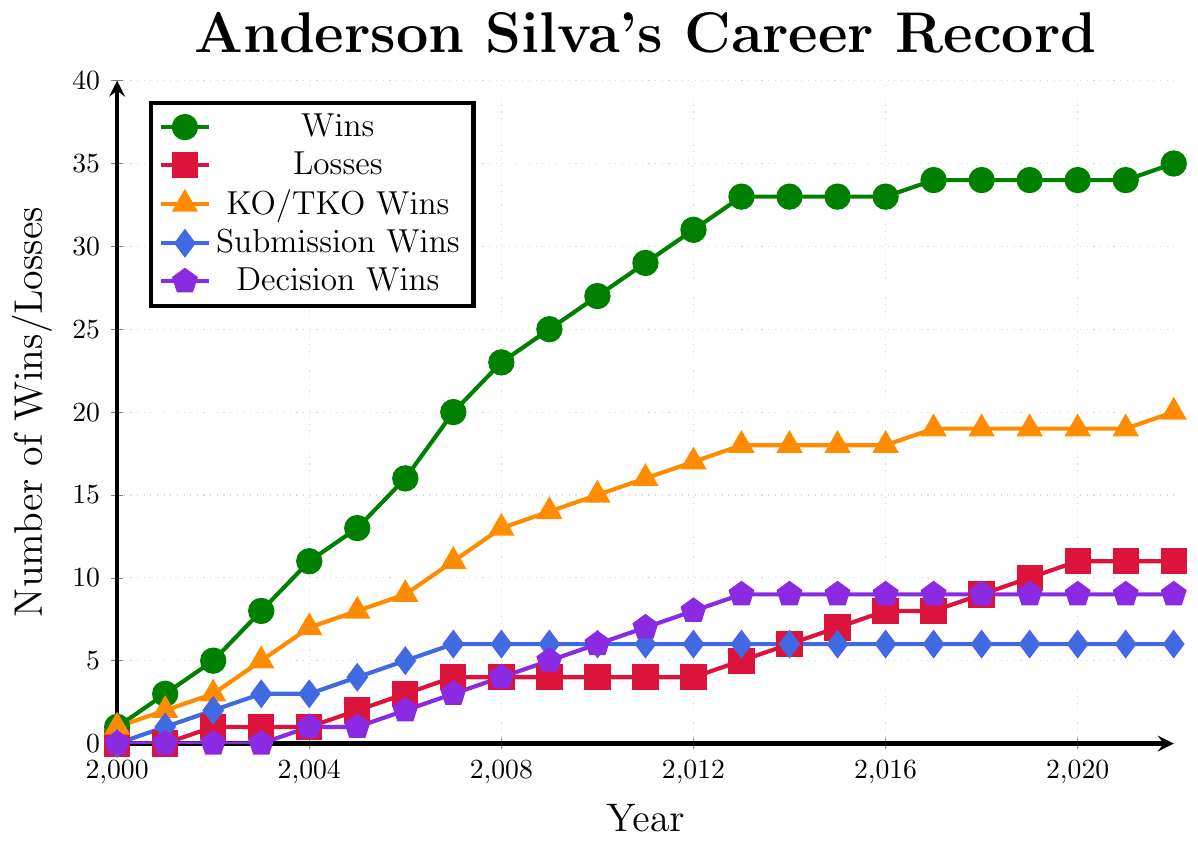What is the total number of wins Anderson Silva had by the end of 2012? In the plot, identify the total wins in 2012, which is represented by the green line and marked by a circular dot. According to the data points in the figure, he had 31 wins by the end of 2012.
Answer: 31 Which year did Anderson Silva have the highest increase in KO/TKO wins? Look at the orange line representing KO/TKO wins and identify the year with the steepest increase. The most significant increase occurs from 2003 to 2004, where the KO/TKO wins went from 5 to 7, an increase of 2.
Answer: 2003-2004 Between 2006 and 2011, did Anderson Silva have more submission wins or decision wins? From the plot, compare the blue line (submission wins) and the purple line (decision wins) between the years 2006 and 2011. Both show an increment, but decision wins (6) exceeded submission wins (5).
Answer: Decision wins By the end of 2010, how many more wins did Anderson Silva achieve by KO/TKO than by submission? In 2010, KO/TKO wins are indicated by the orange line and submission wins by the blue line. KO/TKO wins are 15, and submission wins are 6. Subtract the two to find the difference: 15 - 6 = 9.
Answer: 9 In which year did Anderson Silva first achieve a win by decision? Observe the purple line representing decision wins and identify the first year when a data point appears. The first data point for decision wins appears in 2004.
Answer: 2004 What is the average number of losses per year from 2010 to 2015? Look at the red line representing losses from 2010 to 2015. The losses for these years are 4, 4, 4, 5, 6, and 7 respectively. Sum these values (4 + 4 + 4 + 5 + 6 + 7) = 30, then divide by the number of years (6), resulting in an average of 30/6 = 5.
Answer: 5 From 2014 to 2018, how many more wins by KO/TKO did Anderson Silva have compared to wins by submission? Refer to the orange line (KO/TKO wins) and the blue line (submission wins) between 2014 and 2018. KO/TKO wins stay at 18 in 2014 and increase to 19 in 2017; submission wins remain constant at 6. The difference in 2017 and 2014 is 19 - 6 = 13.
Answer: 13 Which method of victory saw the least change from 2000 to 2013? Observe the lines for KO/TKO, submission, and decision wins. Submission wins (blue line) remain relatively stable with fewer changes compared to KO/TKO and decision wins from 2000 to 2013.
Answer: Submission wins What is the total number of wins by decision by the end of 2017? Refer to the purple line for decision wins and identify the count in 2017, which shows 9 wins.
Answer: 9 